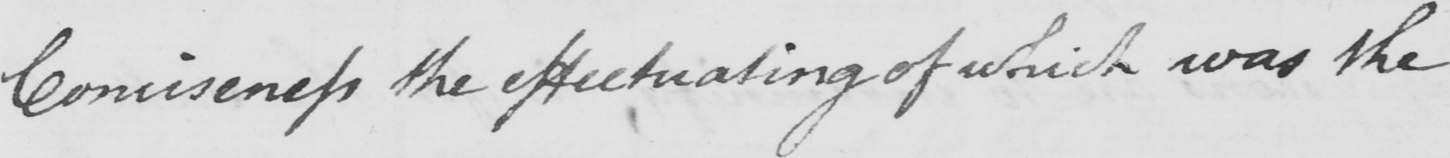What does this handwritten line say? Conciseness the effectuating of which was the 